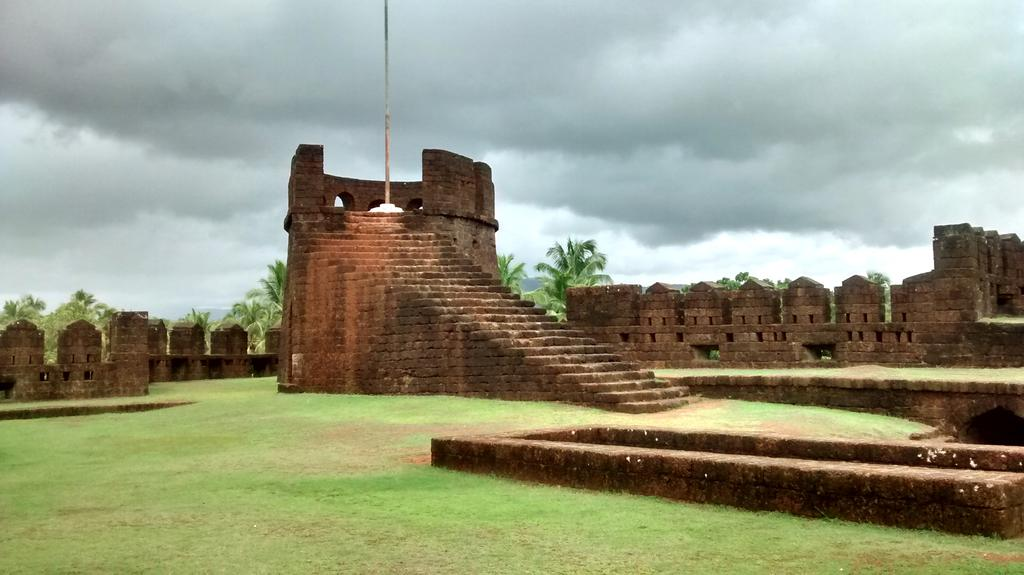What type of structures can be seen in the image? There are walls and steps in the image. What other objects are present in the image? There is a pole in the image. What type of natural elements can be seen in the image? There are trees and grass in the image. How would you describe the sky in the image? The sky is cloudy in the image. Where is the circle located in the image? There is no circle present in the image. What type of frame surrounds the lake in the image? There is no lake or frame present in the image. 